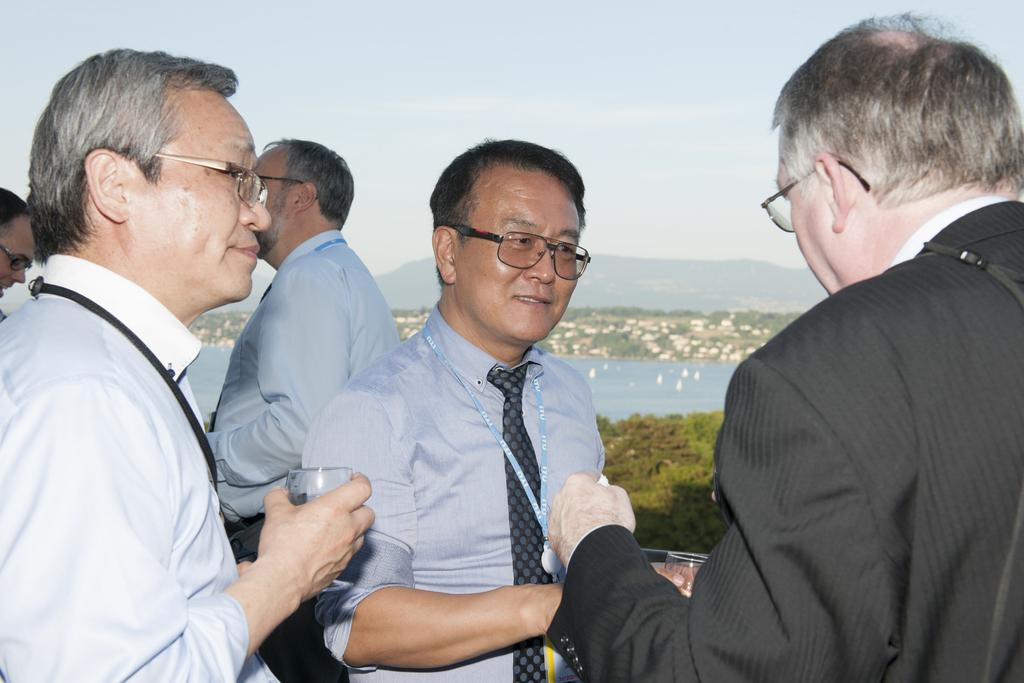What are the people in the image doing? The people in the image are standing and holding glasses. What can be seen in the background of the image? There is water, hills, trees, and the sky visible in the background of the image. What type of club is being used by the men in the image? There are no men or clubs present in the image. What color is the gold object in the image? There is no gold object present in the image. 